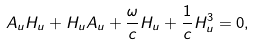<formula> <loc_0><loc_0><loc_500><loc_500>A _ { u } H _ { u } + H _ { u } A _ { u } + \frac { \omega } { c } H _ { u } + \frac { 1 } { c } H _ { u } ^ { 3 } = 0 ,</formula> 